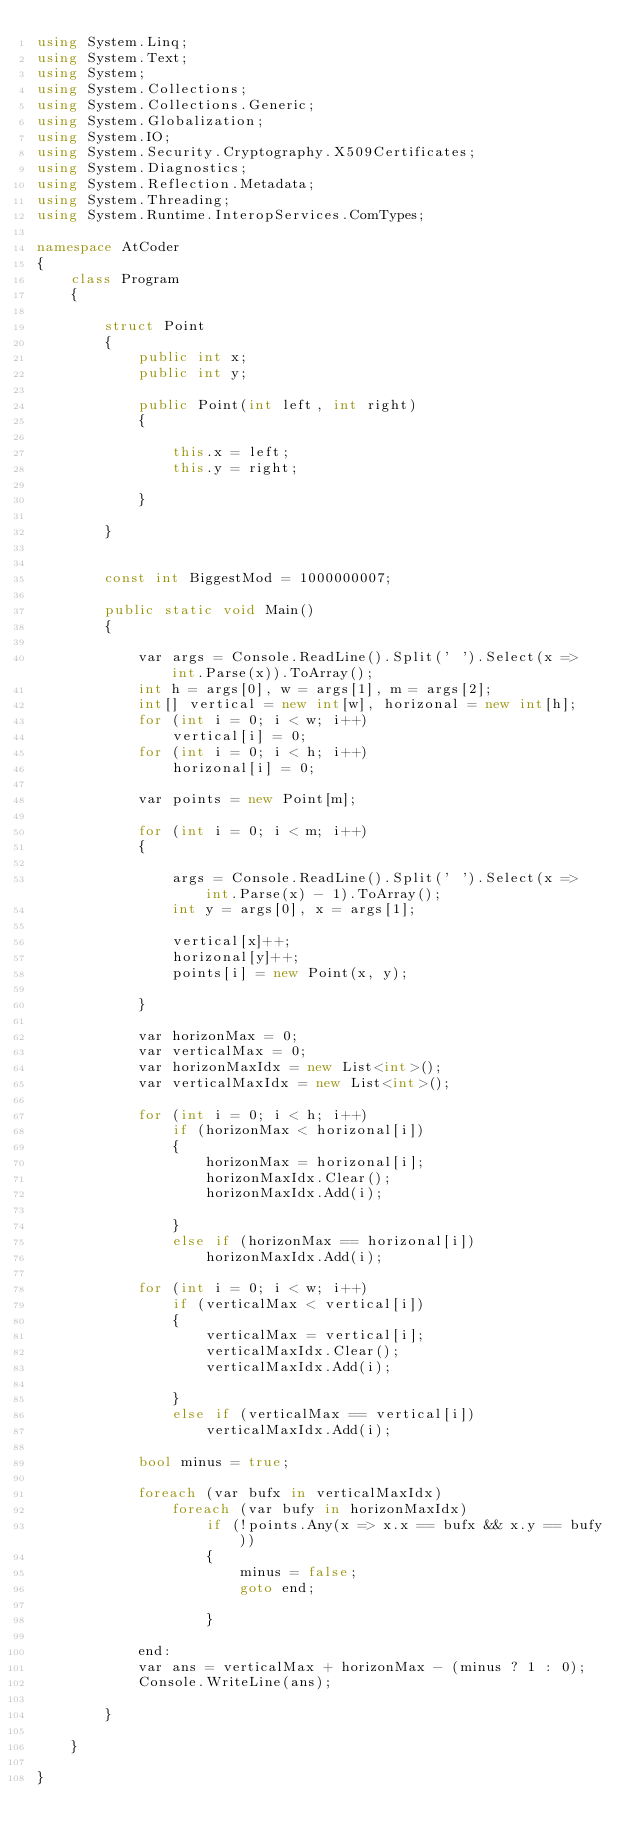<code> <loc_0><loc_0><loc_500><loc_500><_C#_>using System.Linq;
using System.Text;
using System;
using System.Collections;
using System.Collections.Generic;
using System.Globalization;
using System.IO;
using System.Security.Cryptography.X509Certificates;
using System.Diagnostics;
using System.Reflection.Metadata;
using System.Threading;
using System.Runtime.InteropServices.ComTypes;

namespace AtCoder
{
    class Program
    {

        struct Point
        {
            public int x;
            public int y;

            public Point(int left, int right)
            {

                this.x = left;
                this.y = right;

            }

        }


        const int BiggestMod = 1000000007;

        public static void Main()
        {

            var args = Console.ReadLine().Split(' ').Select(x => int.Parse(x)).ToArray();
            int h = args[0], w = args[1], m = args[2];
            int[] vertical = new int[w], horizonal = new int[h];
            for (int i = 0; i < w; i++)
                vertical[i] = 0;
            for (int i = 0; i < h; i++)
                horizonal[i] = 0;

            var points = new Point[m];

            for (int i = 0; i < m; i++)
            {

                args = Console.ReadLine().Split(' ').Select(x => int.Parse(x) - 1).ToArray();
                int y = args[0], x = args[1];

                vertical[x]++;
                horizonal[y]++;
                points[i] = new Point(x, y);

            }

            var horizonMax = 0;
            var verticalMax = 0;
            var horizonMaxIdx = new List<int>();
            var verticalMaxIdx = new List<int>();

            for (int i = 0; i < h; i++)
                if (horizonMax < horizonal[i])
                {
                    horizonMax = horizonal[i];
                    horizonMaxIdx.Clear();
                    horizonMaxIdx.Add(i);

                }
                else if (horizonMax == horizonal[i])
                    horizonMaxIdx.Add(i);

            for (int i = 0; i < w; i++)
                if (verticalMax < vertical[i])
                {
                    verticalMax = vertical[i];
                    verticalMaxIdx.Clear();
                    verticalMaxIdx.Add(i);

                }
                else if (verticalMax == vertical[i])
                    verticalMaxIdx.Add(i);

            bool minus = true;

            foreach (var bufx in verticalMaxIdx)
                foreach (var bufy in horizonMaxIdx)
                    if (!points.Any(x => x.x == bufx && x.y == bufy))
                    {
                        minus = false;
                        goto end;

                    }

            end:
            var ans = verticalMax + horizonMax - (minus ? 1 : 0);
            Console.WriteLine(ans);

        }

    }

}</code> 